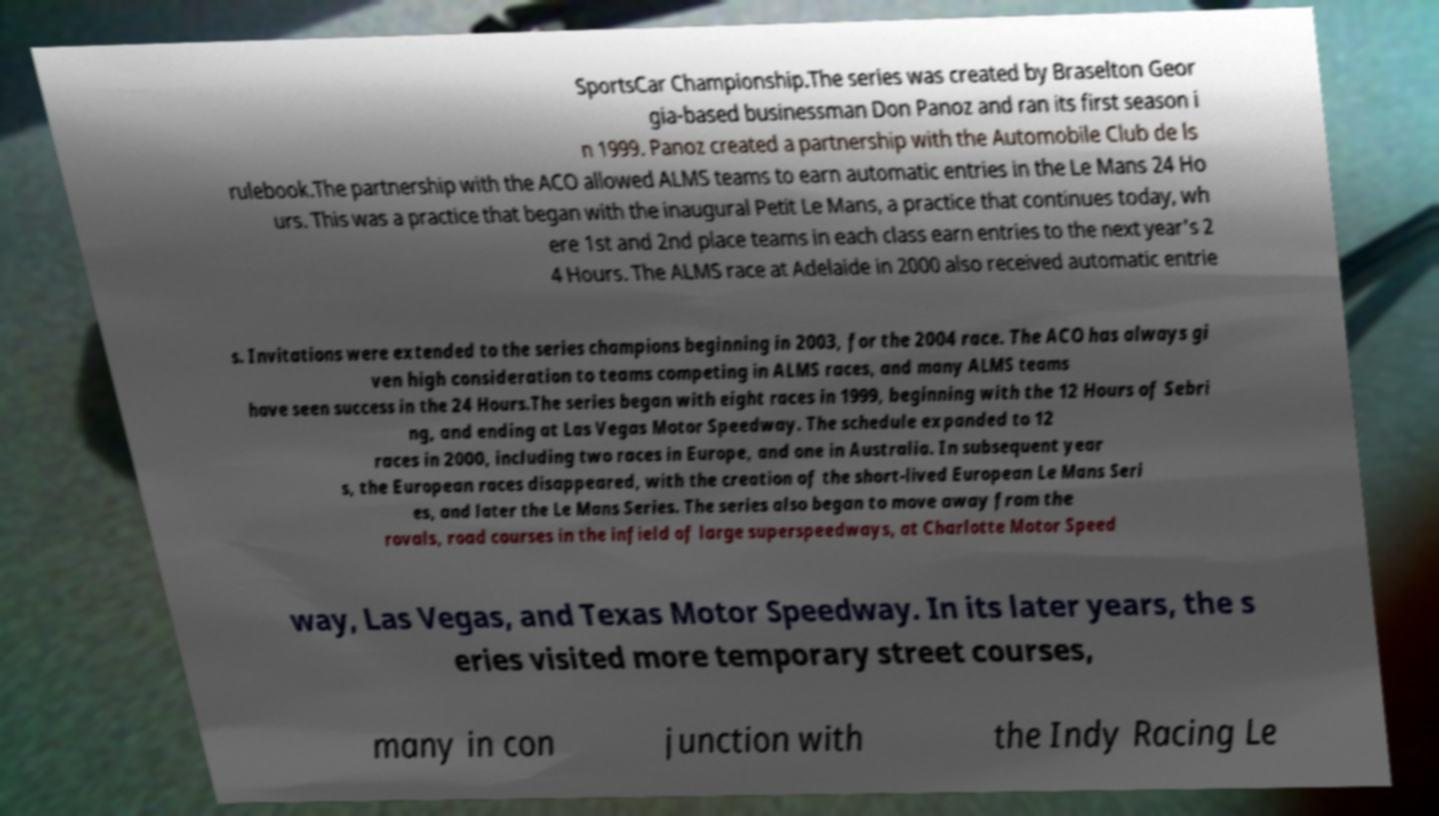Please identify and transcribe the text found in this image. SportsCar Championship.The series was created by Braselton Geor gia-based businessman Don Panoz and ran its first season i n 1999. Panoz created a partnership with the Automobile Club de ls rulebook.The partnership with the ACO allowed ALMS teams to earn automatic entries in the Le Mans 24 Ho urs. This was a practice that began with the inaugural Petit Le Mans, a practice that continues today, wh ere 1st and 2nd place teams in each class earn entries to the next year's 2 4 Hours. The ALMS race at Adelaide in 2000 also received automatic entrie s. Invitations were extended to the series champions beginning in 2003, for the 2004 race. The ACO has always gi ven high consideration to teams competing in ALMS races, and many ALMS teams have seen success in the 24 Hours.The series began with eight races in 1999, beginning with the 12 Hours of Sebri ng, and ending at Las Vegas Motor Speedway. The schedule expanded to 12 races in 2000, including two races in Europe, and one in Australia. In subsequent year s, the European races disappeared, with the creation of the short-lived European Le Mans Seri es, and later the Le Mans Series. The series also began to move away from the rovals, road courses in the infield of large superspeedways, at Charlotte Motor Speed way, Las Vegas, and Texas Motor Speedway. In its later years, the s eries visited more temporary street courses, many in con junction with the Indy Racing Le 